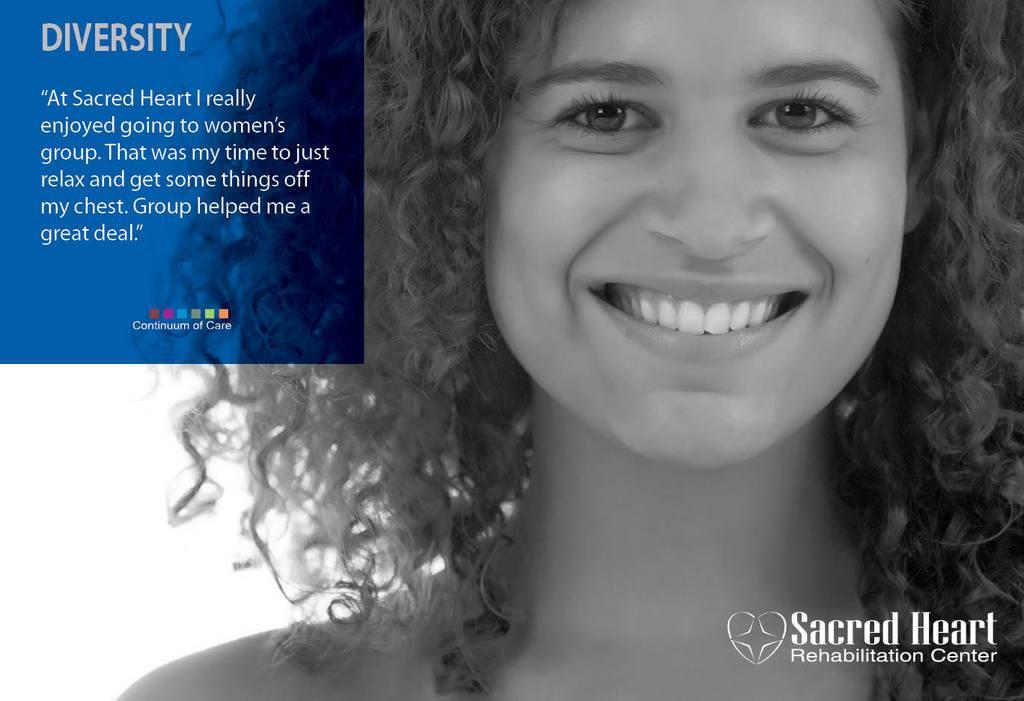How would you summarize this image in a sentence or two? In this image there is a poster with a woman having a smile on her face and some text written on it. 